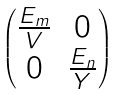Convert formula to latex. <formula><loc_0><loc_0><loc_500><loc_500>\begin{pmatrix} \frac { E _ { m } } { V } & 0 \\ 0 & \frac { E _ { n } } { Y } \end{pmatrix}</formula> 